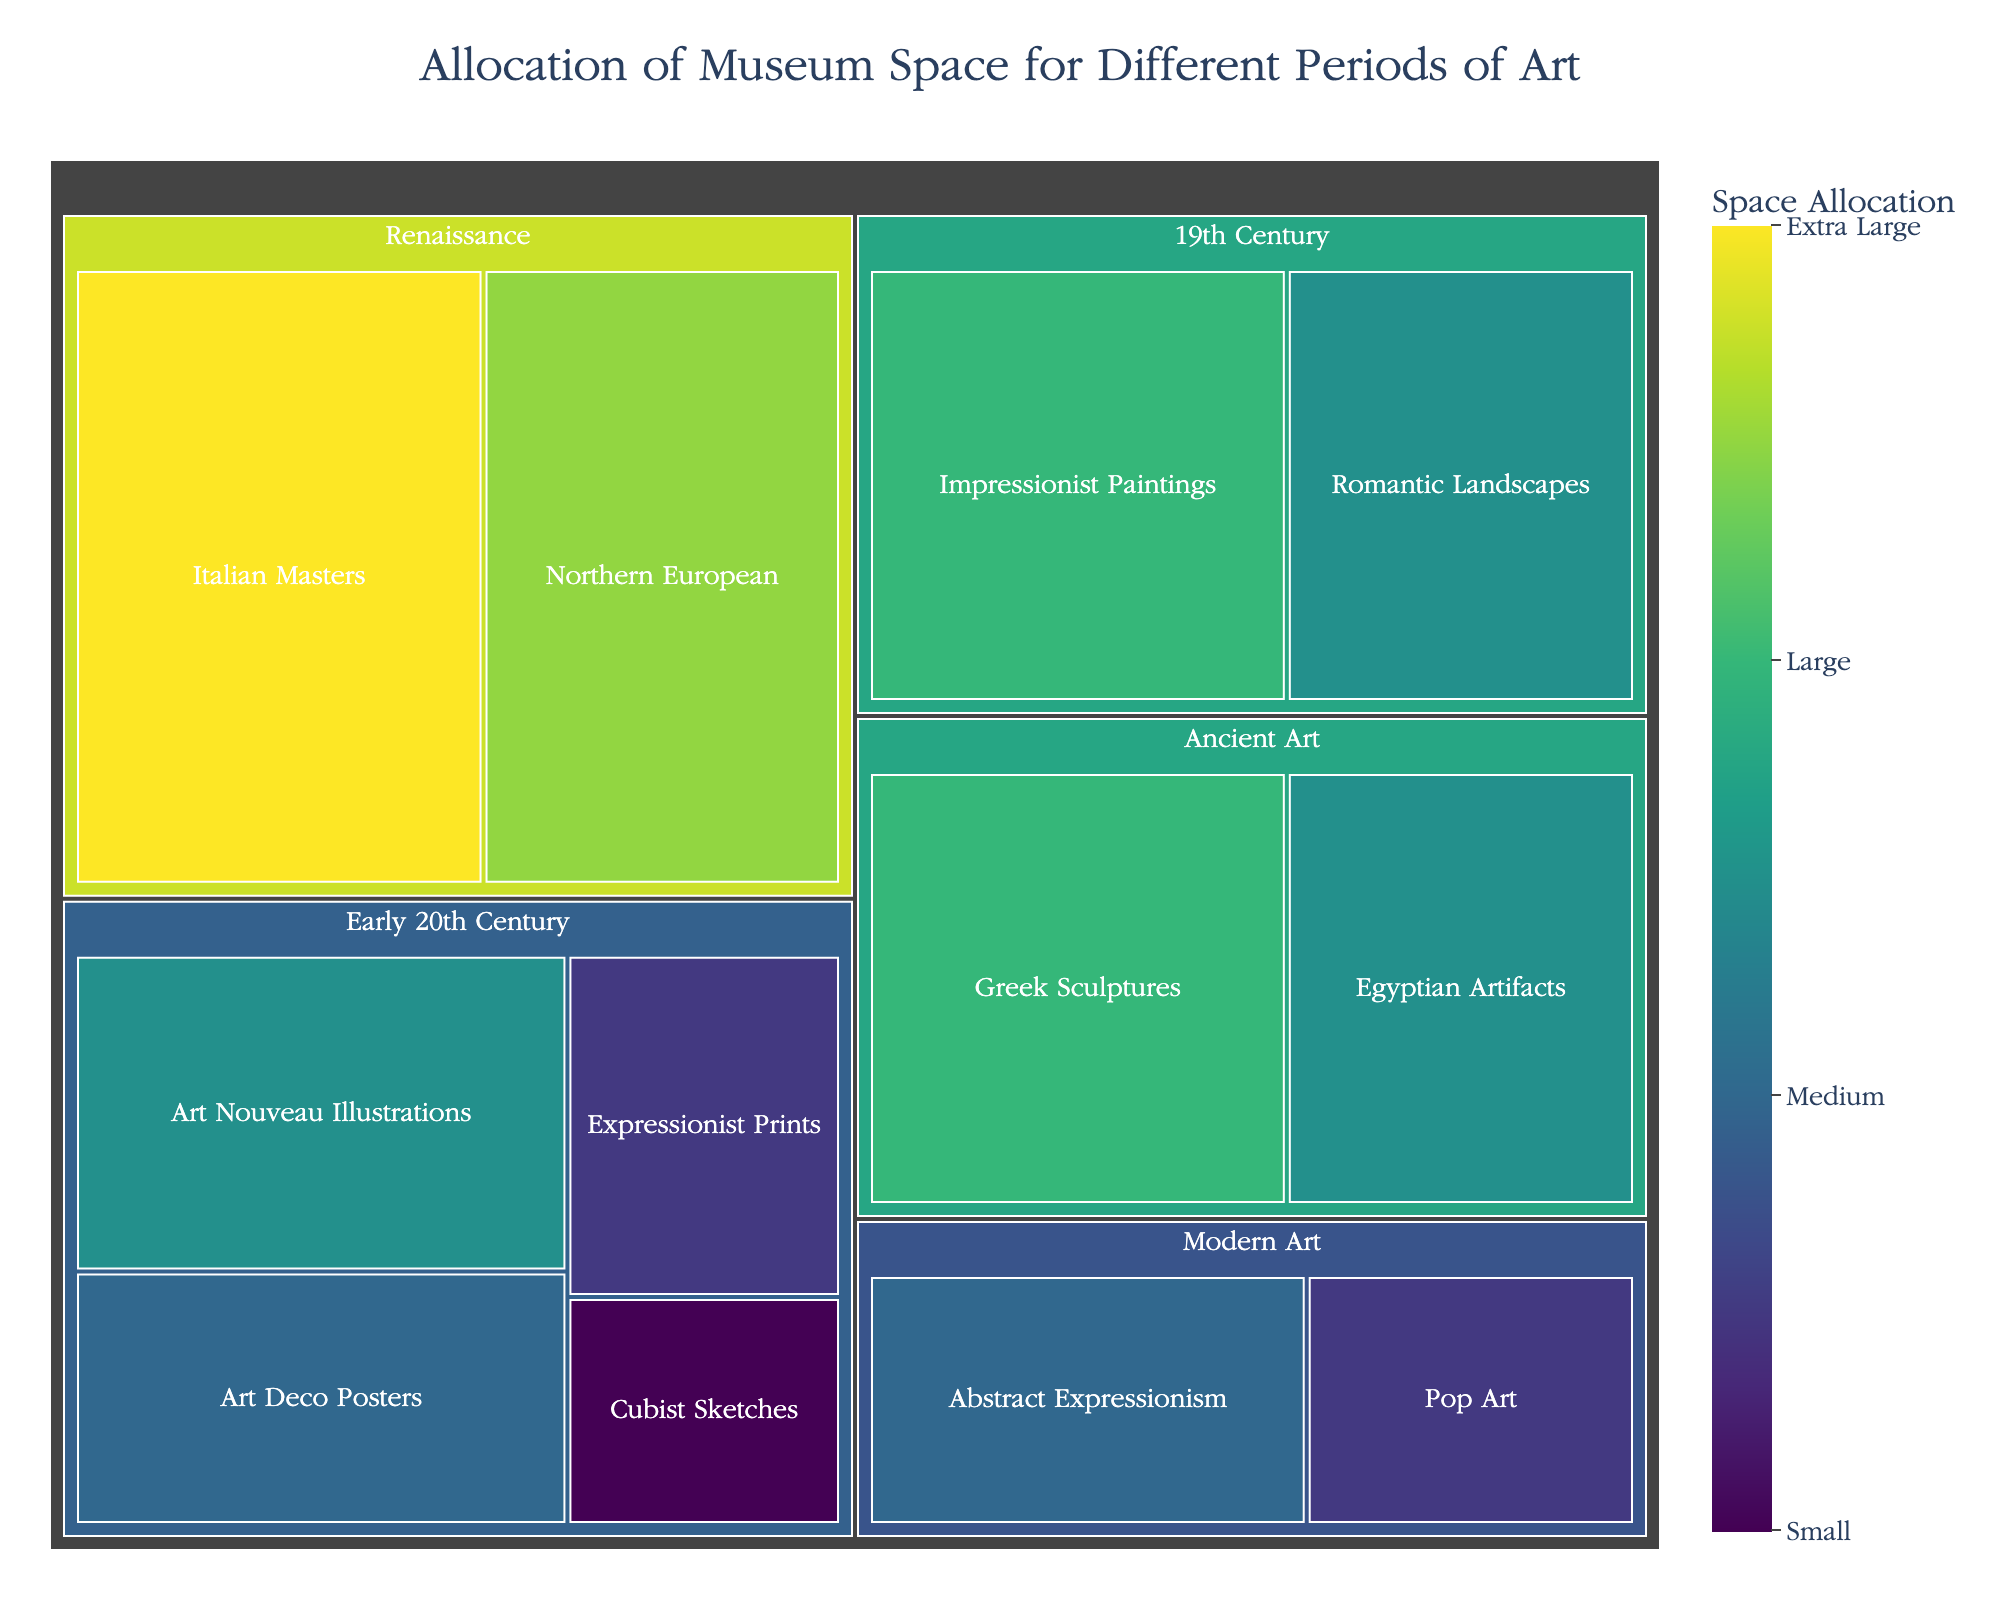What's the title of the figure? The title of the figure is located at the top and is often the largest text in the visual.
Answer: "Allocation of Museum Space for Different Periods of Art" Which category occupies the most space in the museum? By looking at the treemap, identify the largest section.
Answer: Renaissance How much space is allocated to Art Nouveau Illustrations? Locate the section for "Art Nouveau Illustrations" within the "Early 20th Century" category and note the value.
Answer: 25 Which has more allocated space, Impressionist Paintings or Art Deco Posters? Compare the space allocation values for "Impressionist Paintings" and "Art Deco Posters".
Answer: Impressionist Paintings What is the total space allocated for Early 20th Century art? Add up the space allocations for all subcategories under "Early 20th Century" (Art Nouveau Illustrations, Art Deco Posters, Expressionist Prints, Cubist Sketches). The values are 25, 20, 15, and 10, respectively. Sum them: 25 + 20 + 15 + 10 = 70.
Answer: 70 How does the space allocated to Italian Masters compare to Ancient Greek Sculptures? Identify and compare the values for "Italian Masters" in the Renaissance category and "Greek Sculptures" in the Ancient Art category.
Answer: Italian Masters What category has the smallest allocation and which subcategory within it occupies the least space? Identify the category with the smallest overall space allocation by visual assessment. Then, within that category, identify the subcategory with the smallest value.
Answer: Early 20th Century, Cubist Sketches What is the collective space allocation for Renaissance and Modern Art categories? Add up the values for all subcategories within Renaissance (Italian Masters: 40, Northern European: 35) and Modern Art (Abstract Expressionism: 20, Pop Art: 15). Calculate the total: (40 + 35) + (20 + 15) = 110.
Answer: 110 Which period has more space dedicated to it, 19th Century or Ancient Art? Compare the total space allocation values by summing up subcategory values for each period. 19th Century: (Impressionist Paintings: 30, Romantic Landscapes: 25) = 55; Ancient Art: (Greek Sculptures: 30, Egyptian Artifacts: 25) = 55. The allocations are equal.
Answer: Equal 